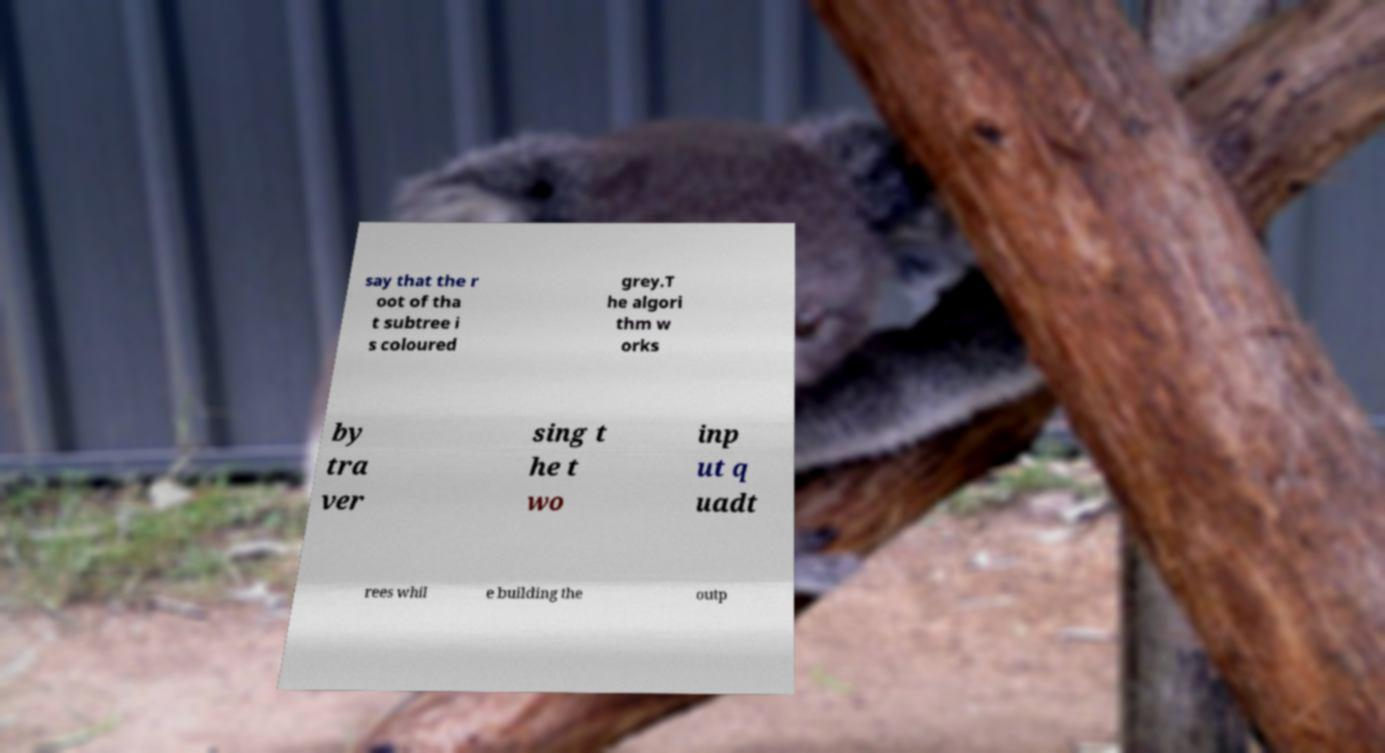Please read and relay the text visible in this image. What does it say? say that the r oot of tha t subtree i s coloured grey.T he algori thm w orks by tra ver sing t he t wo inp ut q uadt rees whil e building the outp 